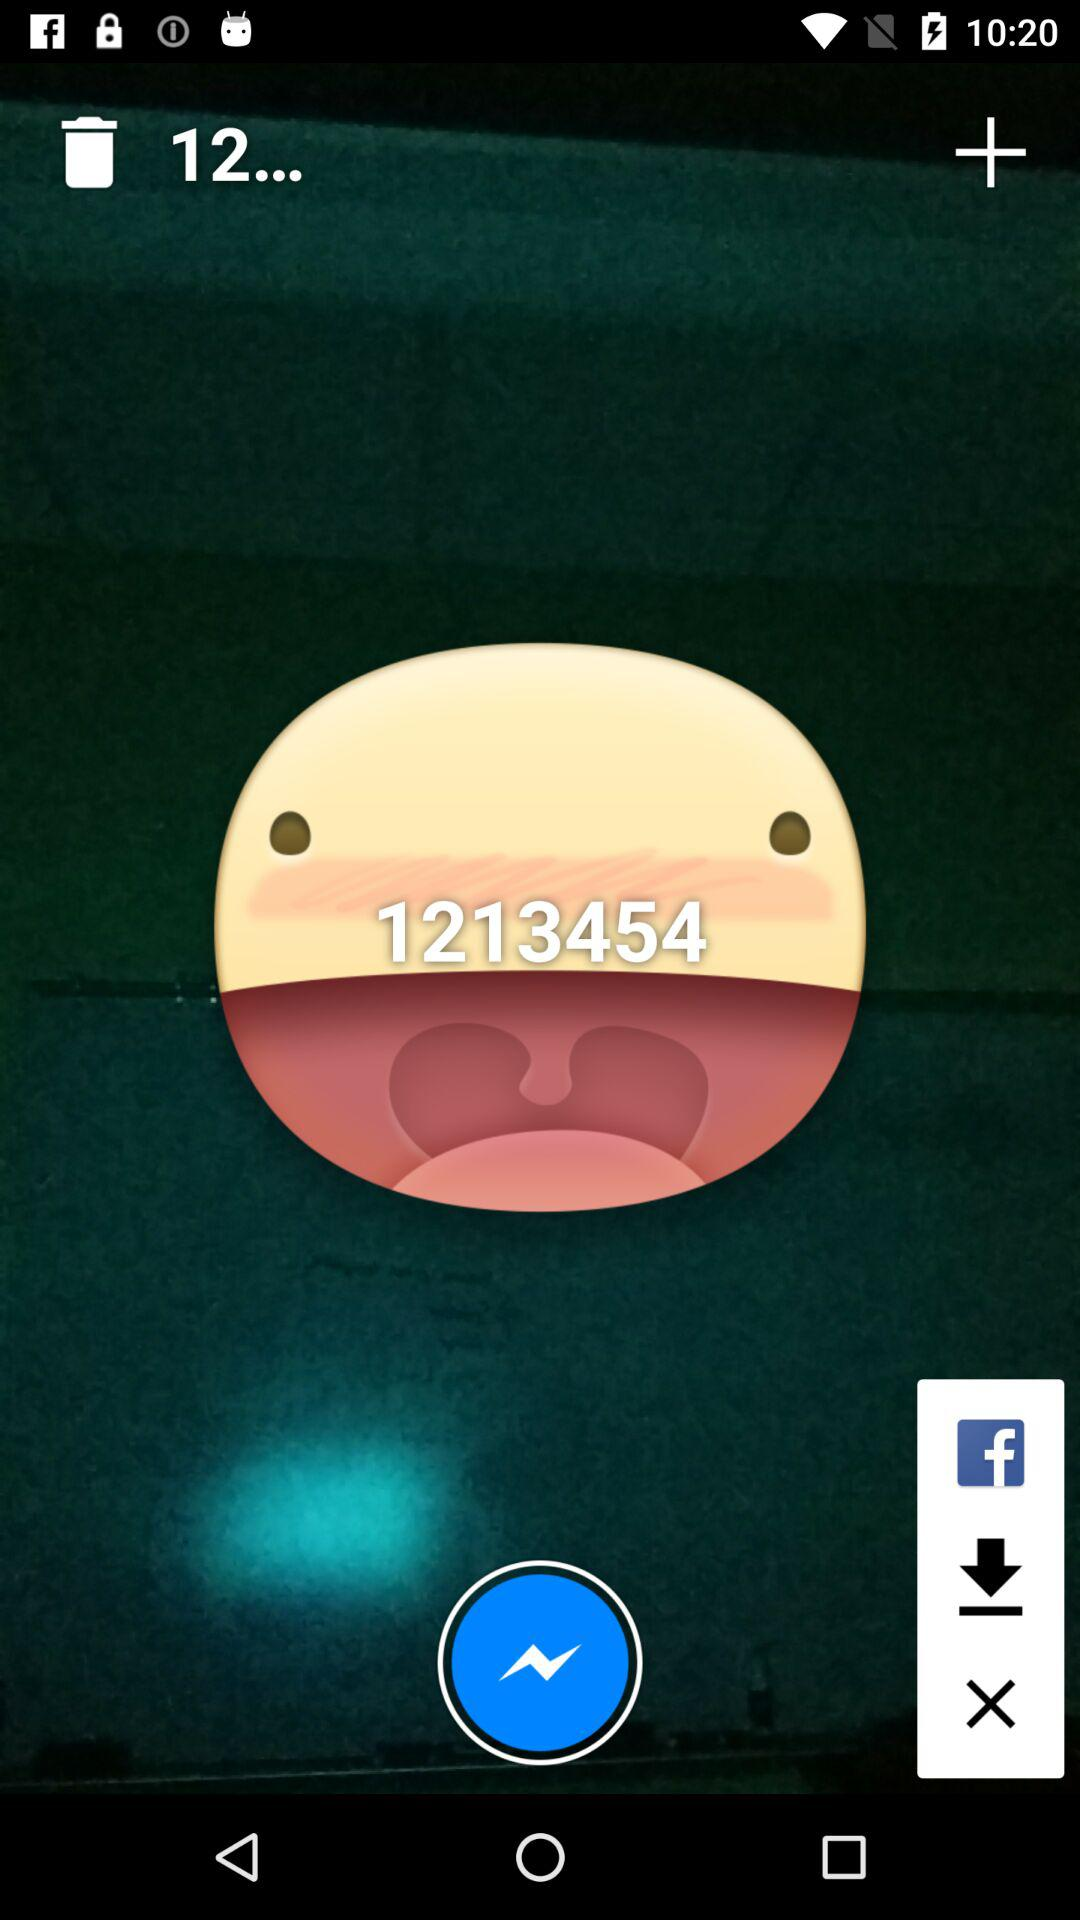What is the number? The number is 1213454. 